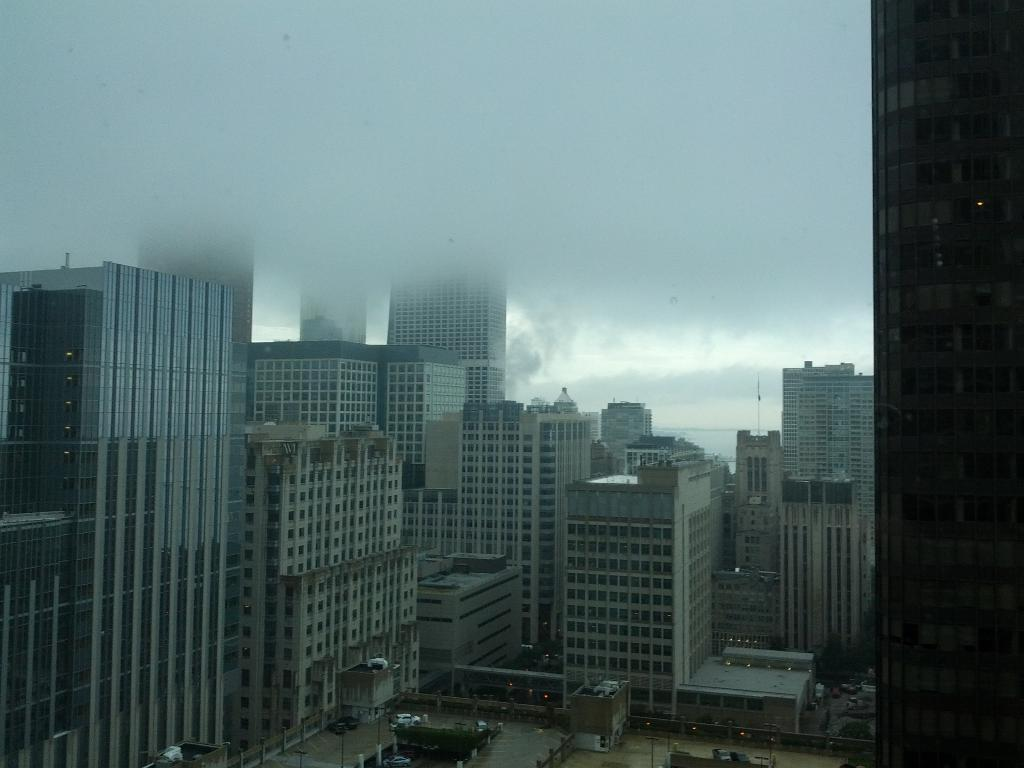What type of structures can be seen in the image? There are many buildings and skyscrapers in the image. What can be seen in the sky in the image? Clouds are visible at the top of the image. Are there any specific features on the roof of a building in the image? Yes, there are poles on the roof of a building at the bottom of the image. Can you see the people playing on the island in the image? There is no island present in the image, and therefore no people playing on it. 